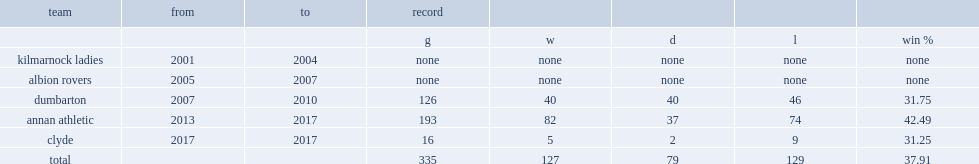Which team did chapman begin his managerial career with, from 2001 and 2004? Kilmarnock ladies. 